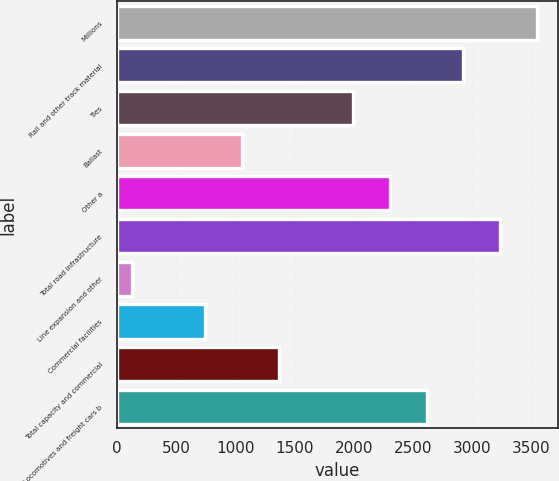Convert chart to OTSL. <chart><loc_0><loc_0><loc_500><loc_500><bar_chart><fcel>Millions<fcel>Rail and other track material<fcel>Ties<fcel>Ballast<fcel>Other a<fcel>Total road infrastructure<fcel>Line expansion and other<fcel>Commercial facilities<fcel>Total capacity and commercial<fcel>Locomotives and freight cars b<nl><fcel>3549.4<fcel>2926.6<fcel>1992.4<fcel>1058.2<fcel>2303.8<fcel>3238<fcel>124<fcel>746.8<fcel>1369.6<fcel>2615.2<nl></chart> 